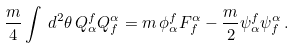Convert formula to latex. <formula><loc_0><loc_0><loc_500><loc_500>\frac { m } { 4 } \int \, d ^ { 2 } \theta \, Q _ { \alpha } ^ { f } Q _ { f } ^ { \alpha } = m \, \phi _ { \alpha } ^ { f } F _ { f } ^ { \alpha } - \frac { m } { 2 } \psi _ { \alpha } ^ { f } \psi _ { f } ^ { \alpha } \, .</formula> 